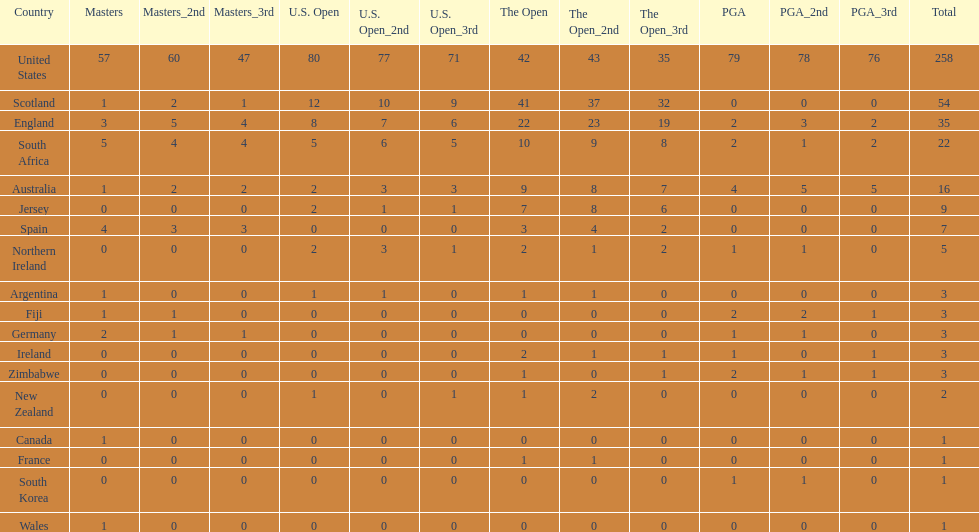Is the united stated or scotland better? United States. 